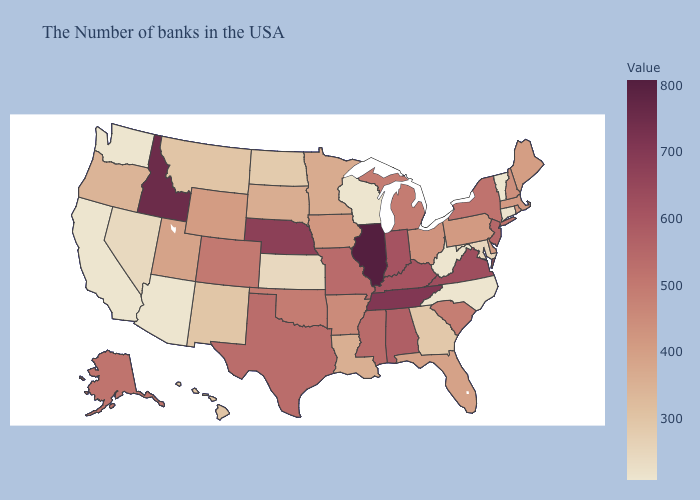Does New Jersey have the highest value in the Northeast?
Short answer required. Yes. Does Alabama have the lowest value in the USA?
Give a very brief answer. No. Among the states that border Maryland , does Virginia have the highest value?
Quick response, please. Yes. Does West Virginia have the lowest value in the USA?
Keep it brief. Yes. Does Massachusetts have the lowest value in the USA?
Write a very short answer. No. Which states have the lowest value in the USA?
Quick response, please. Vermont, North Carolina, West Virginia, Wisconsin, Arizona, California, Washington. 